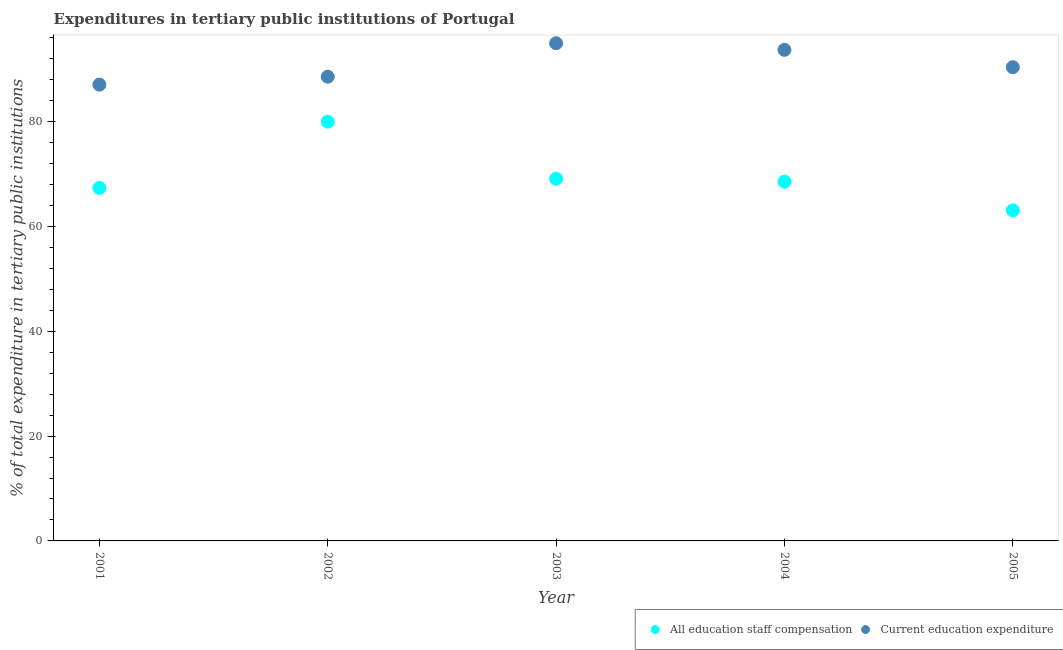How many different coloured dotlines are there?
Your response must be concise. 2. Is the number of dotlines equal to the number of legend labels?
Provide a short and direct response. Yes. What is the expenditure in staff compensation in 2005?
Give a very brief answer. 63.05. Across all years, what is the maximum expenditure in education?
Provide a succinct answer. 94.93. Across all years, what is the minimum expenditure in education?
Your answer should be very brief. 87.04. In which year was the expenditure in education maximum?
Ensure brevity in your answer.  2003. What is the total expenditure in staff compensation in the graph?
Provide a short and direct response. 347.97. What is the difference between the expenditure in education in 2002 and that in 2003?
Make the answer very short. -6.39. What is the difference between the expenditure in education in 2001 and the expenditure in staff compensation in 2004?
Your response must be concise. 18.51. What is the average expenditure in staff compensation per year?
Offer a terse response. 69.59. In the year 2003, what is the difference between the expenditure in staff compensation and expenditure in education?
Provide a short and direct response. -25.84. In how many years, is the expenditure in education greater than 16 %?
Provide a succinct answer. 5. What is the ratio of the expenditure in education in 2001 to that in 2002?
Offer a very short reply. 0.98. What is the difference between the highest and the second highest expenditure in education?
Provide a succinct answer. 1.27. What is the difference between the highest and the lowest expenditure in staff compensation?
Keep it short and to the point. 16.92. Is the expenditure in staff compensation strictly less than the expenditure in education over the years?
Offer a terse response. Yes. How many years are there in the graph?
Make the answer very short. 5. Are the values on the major ticks of Y-axis written in scientific E-notation?
Your answer should be very brief. No. Does the graph contain any zero values?
Provide a short and direct response. No. Does the graph contain grids?
Your answer should be very brief. No. Where does the legend appear in the graph?
Ensure brevity in your answer.  Bottom right. How many legend labels are there?
Your response must be concise. 2. How are the legend labels stacked?
Offer a very short reply. Horizontal. What is the title of the graph?
Your response must be concise. Expenditures in tertiary public institutions of Portugal. What is the label or title of the X-axis?
Your answer should be compact. Year. What is the label or title of the Y-axis?
Offer a terse response. % of total expenditure in tertiary public institutions. What is the % of total expenditure in tertiary public institutions in All education staff compensation in 2001?
Your answer should be compact. 67.33. What is the % of total expenditure in tertiary public institutions of Current education expenditure in 2001?
Give a very brief answer. 87.04. What is the % of total expenditure in tertiary public institutions of All education staff compensation in 2002?
Provide a succinct answer. 79.97. What is the % of total expenditure in tertiary public institutions of Current education expenditure in 2002?
Give a very brief answer. 88.55. What is the % of total expenditure in tertiary public institutions of All education staff compensation in 2003?
Provide a short and direct response. 69.1. What is the % of total expenditure in tertiary public institutions in Current education expenditure in 2003?
Your answer should be very brief. 94.93. What is the % of total expenditure in tertiary public institutions in All education staff compensation in 2004?
Your response must be concise. 68.52. What is the % of total expenditure in tertiary public institutions in Current education expenditure in 2004?
Your answer should be compact. 93.67. What is the % of total expenditure in tertiary public institutions in All education staff compensation in 2005?
Offer a very short reply. 63.05. What is the % of total expenditure in tertiary public institutions in Current education expenditure in 2005?
Give a very brief answer. 90.36. Across all years, what is the maximum % of total expenditure in tertiary public institutions of All education staff compensation?
Make the answer very short. 79.97. Across all years, what is the maximum % of total expenditure in tertiary public institutions of Current education expenditure?
Your response must be concise. 94.93. Across all years, what is the minimum % of total expenditure in tertiary public institutions in All education staff compensation?
Provide a short and direct response. 63.05. Across all years, what is the minimum % of total expenditure in tertiary public institutions of Current education expenditure?
Your answer should be compact. 87.04. What is the total % of total expenditure in tertiary public institutions in All education staff compensation in the graph?
Offer a very short reply. 347.97. What is the total % of total expenditure in tertiary public institutions in Current education expenditure in the graph?
Your answer should be very brief. 454.55. What is the difference between the % of total expenditure in tertiary public institutions of All education staff compensation in 2001 and that in 2002?
Offer a very short reply. -12.65. What is the difference between the % of total expenditure in tertiary public institutions in Current education expenditure in 2001 and that in 2002?
Make the answer very short. -1.51. What is the difference between the % of total expenditure in tertiary public institutions of All education staff compensation in 2001 and that in 2003?
Make the answer very short. -1.77. What is the difference between the % of total expenditure in tertiary public institutions of Current education expenditure in 2001 and that in 2003?
Offer a terse response. -7.9. What is the difference between the % of total expenditure in tertiary public institutions of All education staff compensation in 2001 and that in 2004?
Ensure brevity in your answer.  -1.2. What is the difference between the % of total expenditure in tertiary public institutions of Current education expenditure in 2001 and that in 2004?
Provide a succinct answer. -6.63. What is the difference between the % of total expenditure in tertiary public institutions in All education staff compensation in 2001 and that in 2005?
Keep it short and to the point. 4.27. What is the difference between the % of total expenditure in tertiary public institutions of Current education expenditure in 2001 and that in 2005?
Your answer should be very brief. -3.32. What is the difference between the % of total expenditure in tertiary public institutions of All education staff compensation in 2002 and that in 2003?
Offer a very short reply. 10.87. What is the difference between the % of total expenditure in tertiary public institutions of Current education expenditure in 2002 and that in 2003?
Your answer should be very brief. -6.39. What is the difference between the % of total expenditure in tertiary public institutions of All education staff compensation in 2002 and that in 2004?
Your answer should be very brief. 11.45. What is the difference between the % of total expenditure in tertiary public institutions in Current education expenditure in 2002 and that in 2004?
Offer a terse response. -5.12. What is the difference between the % of total expenditure in tertiary public institutions of All education staff compensation in 2002 and that in 2005?
Provide a succinct answer. 16.92. What is the difference between the % of total expenditure in tertiary public institutions of Current education expenditure in 2002 and that in 2005?
Your answer should be very brief. -1.81. What is the difference between the % of total expenditure in tertiary public institutions of All education staff compensation in 2003 and that in 2004?
Keep it short and to the point. 0.58. What is the difference between the % of total expenditure in tertiary public institutions of Current education expenditure in 2003 and that in 2004?
Your response must be concise. 1.27. What is the difference between the % of total expenditure in tertiary public institutions in All education staff compensation in 2003 and that in 2005?
Offer a very short reply. 6.05. What is the difference between the % of total expenditure in tertiary public institutions of Current education expenditure in 2003 and that in 2005?
Provide a succinct answer. 4.58. What is the difference between the % of total expenditure in tertiary public institutions of All education staff compensation in 2004 and that in 2005?
Provide a succinct answer. 5.47. What is the difference between the % of total expenditure in tertiary public institutions in Current education expenditure in 2004 and that in 2005?
Provide a succinct answer. 3.31. What is the difference between the % of total expenditure in tertiary public institutions of All education staff compensation in 2001 and the % of total expenditure in tertiary public institutions of Current education expenditure in 2002?
Your answer should be very brief. -21.22. What is the difference between the % of total expenditure in tertiary public institutions in All education staff compensation in 2001 and the % of total expenditure in tertiary public institutions in Current education expenditure in 2003?
Give a very brief answer. -27.61. What is the difference between the % of total expenditure in tertiary public institutions of All education staff compensation in 2001 and the % of total expenditure in tertiary public institutions of Current education expenditure in 2004?
Ensure brevity in your answer.  -26.34. What is the difference between the % of total expenditure in tertiary public institutions in All education staff compensation in 2001 and the % of total expenditure in tertiary public institutions in Current education expenditure in 2005?
Provide a short and direct response. -23.03. What is the difference between the % of total expenditure in tertiary public institutions of All education staff compensation in 2002 and the % of total expenditure in tertiary public institutions of Current education expenditure in 2003?
Your response must be concise. -14.96. What is the difference between the % of total expenditure in tertiary public institutions in All education staff compensation in 2002 and the % of total expenditure in tertiary public institutions in Current education expenditure in 2004?
Offer a very short reply. -13.7. What is the difference between the % of total expenditure in tertiary public institutions of All education staff compensation in 2002 and the % of total expenditure in tertiary public institutions of Current education expenditure in 2005?
Provide a succinct answer. -10.39. What is the difference between the % of total expenditure in tertiary public institutions of All education staff compensation in 2003 and the % of total expenditure in tertiary public institutions of Current education expenditure in 2004?
Make the answer very short. -24.57. What is the difference between the % of total expenditure in tertiary public institutions of All education staff compensation in 2003 and the % of total expenditure in tertiary public institutions of Current education expenditure in 2005?
Your answer should be very brief. -21.26. What is the difference between the % of total expenditure in tertiary public institutions of All education staff compensation in 2004 and the % of total expenditure in tertiary public institutions of Current education expenditure in 2005?
Offer a very short reply. -21.84. What is the average % of total expenditure in tertiary public institutions in All education staff compensation per year?
Offer a terse response. 69.59. What is the average % of total expenditure in tertiary public institutions of Current education expenditure per year?
Make the answer very short. 90.91. In the year 2001, what is the difference between the % of total expenditure in tertiary public institutions of All education staff compensation and % of total expenditure in tertiary public institutions of Current education expenditure?
Provide a succinct answer. -19.71. In the year 2002, what is the difference between the % of total expenditure in tertiary public institutions in All education staff compensation and % of total expenditure in tertiary public institutions in Current education expenditure?
Your answer should be very brief. -8.58. In the year 2003, what is the difference between the % of total expenditure in tertiary public institutions of All education staff compensation and % of total expenditure in tertiary public institutions of Current education expenditure?
Provide a succinct answer. -25.84. In the year 2004, what is the difference between the % of total expenditure in tertiary public institutions of All education staff compensation and % of total expenditure in tertiary public institutions of Current education expenditure?
Offer a very short reply. -25.15. In the year 2005, what is the difference between the % of total expenditure in tertiary public institutions of All education staff compensation and % of total expenditure in tertiary public institutions of Current education expenditure?
Your answer should be very brief. -27.31. What is the ratio of the % of total expenditure in tertiary public institutions in All education staff compensation in 2001 to that in 2002?
Ensure brevity in your answer.  0.84. What is the ratio of the % of total expenditure in tertiary public institutions of Current education expenditure in 2001 to that in 2002?
Your response must be concise. 0.98. What is the ratio of the % of total expenditure in tertiary public institutions of All education staff compensation in 2001 to that in 2003?
Your answer should be compact. 0.97. What is the ratio of the % of total expenditure in tertiary public institutions of Current education expenditure in 2001 to that in 2003?
Provide a succinct answer. 0.92. What is the ratio of the % of total expenditure in tertiary public institutions of All education staff compensation in 2001 to that in 2004?
Provide a short and direct response. 0.98. What is the ratio of the % of total expenditure in tertiary public institutions of Current education expenditure in 2001 to that in 2004?
Make the answer very short. 0.93. What is the ratio of the % of total expenditure in tertiary public institutions in All education staff compensation in 2001 to that in 2005?
Provide a succinct answer. 1.07. What is the ratio of the % of total expenditure in tertiary public institutions in Current education expenditure in 2001 to that in 2005?
Offer a very short reply. 0.96. What is the ratio of the % of total expenditure in tertiary public institutions of All education staff compensation in 2002 to that in 2003?
Give a very brief answer. 1.16. What is the ratio of the % of total expenditure in tertiary public institutions of Current education expenditure in 2002 to that in 2003?
Offer a terse response. 0.93. What is the ratio of the % of total expenditure in tertiary public institutions of All education staff compensation in 2002 to that in 2004?
Your answer should be compact. 1.17. What is the ratio of the % of total expenditure in tertiary public institutions in Current education expenditure in 2002 to that in 2004?
Your answer should be very brief. 0.95. What is the ratio of the % of total expenditure in tertiary public institutions in All education staff compensation in 2002 to that in 2005?
Make the answer very short. 1.27. What is the ratio of the % of total expenditure in tertiary public institutions in All education staff compensation in 2003 to that in 2004?
Make the answer very short. 1.01. What is the ratio of the % of total expenditure in tertiary public institutions in Current education expenditure in 2003 to that in 2004?
Your answer should be very brief. 1.01. What is the ratio of the % of total expenditure in tertiary public institutions in All education staff compensation in 2003 to that in 2005?
Your answer should be compact. 1.1. What is the ratio of the % of total expenditure in tertiary public institutions in Current education expenditure in 2003 to that in 2005?
Offer a very short reply. 1.05. What is the ratio of the % of total expenditure in tertiary public institutions of All education staff compensation in 2004 to that in 2005?
Your answer should be very brief. 1.09. What is the ratio of the % of total expenditure in tertiary public institutions in Current education expenditure in 2004 to that in 2005?
Offer a very short reply. 1.04. What is the difference between the highest and the second highest % of total expenditure in tertiary public institutions in All education staff compensation?
Ensure brevity in your answer.  10.87. What is the difference between the highest and the second highest % of total expenditure in tertiary public institutions of Current education expenditure?
Provide a short and direct response. 1.27. What is the difference between the highest and the lowest % of total expenditure in tertiary public institutions of All education staff compensation?
Offer a very short reply. 16.92. What is the difference between the highest and the lowest % of total expenditure in tertiary public institutions in Current education expenditure?
Provide a succinct answer. 7.9. 